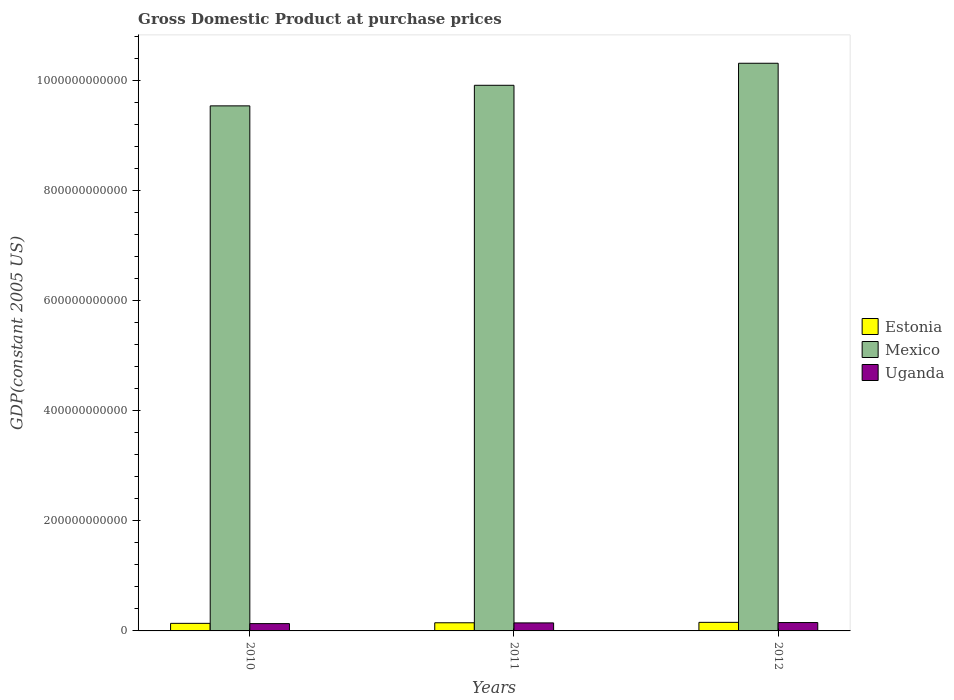How many different coloured bars are there?
Ensure brevity in your answer.  3. How many groups of bars are there?
Offer a terse response. 3. Are the number of bars per tick equal to the number of legend labels?
Offer a terse response. Yes. How many bars are there on the 1st tick from the right?
Ensure brevity in your answer.  3. What is the label of the 1st group of bars from the left?
Your answer should be very brief. 2010. In how many cases, is the number of bars for a given year not equal to the number of legend labels?
Ensure brevity in your answer.  0. What is the GDP at purchase prices in Mexico in 2012?
Your response must be concise. 1.03e+12. Across all years, what is the maximum GDP at purchase prices in Uganda?
Ensure brevity in your answer.  1.52e+1. Across all years, what is the minimum GDP at purchase prices in Estonia?
Give a very brief answer. 1.38e+1. In which year was the GDP at purchase prices in Uganda minimum?
Keep it short and to the point. 2010. What is the total GDP at purchase prices in Estonia in the graph?
Your answer should be compact. 4.41e+1. What is the difference between the GDP at purchase prices in Uganda in 2010 and that in 2012?
Give a very brief answer. -1.93e+09. What is the difference between the GDP at purchase prices in Mexico in 2011 and the GDP at purchase prices in Estonia in 2012?
Provide a short and direct response. 9.75e+11. What is the average GDP at purchase prices in Uganda per year?
Your answer should be very brief. 1.43e+1. In the year 2012, what is the difference between the GDP at purchase prices in Estonia and GDP at purchase prices in Uganda?
Provide a succinct answer. 3.61e+08. What is the ratio of the GDP at purchase prices in Uganda in 2010 to that in 2011?
Offer a terse response. 0.91. Is the GDP at purchase prices in Mexico in 2011 less than that in 2012?
Your answer should be very brief. Yes. Is the difference between the GDP at purchase prices in Estonia in 2010 and 2012 greater than the difference between the GDP at purchase prices in Uganda in 2010 and 2012?
Ensure brevity in your answer.  Yes. What is the difference between the highest and the second highest GDP at purchase prices in Estonia?
Give a very brief answer. 7.67e+08. What is the difference between the highest and the lowest GDP at purchase prices in Uganda?
Offer a terse response. 1.93e+09. In how many years, is the GDP at purchase prices in Estonia greater than the average GDP at purchase prices in Estonia taken over all years?
Offer a very short reply. 2. Is the sum of the GDP at purchase prices in Mexico in 2010 and 2012 greater than the maximum GDP at purchase prices in Uganda across all years?
Offer a very short reply. Yes. What does the 3rd bar from the left in 2011 represents?
Your response must be concise. Uganda. What does the 2nd bar from the right in 2012 represents?
Provide a short and direct response. Mexico. Is it the case that in every year, the sum of the GDP at purchase prices in Uganda and GDP at purchase prices in Mexico is greater than the GDP at purchase prices in Estonia?
Make the answer very short. Yes. What is the difference between two consecutive major ticks on the Y-axis?
Keep it short and to the point. 2.00e+11. Does the graph contain grids?
Ensure brevity in your answer.  No. Where does the legend appear in the graph?
Your answer should be very brief. Center right. What is the title of the graph?
Keep it short and to the point. Gross Domestic Product at purchase prices. Does "Portugal" appear as one of the legend labels in the graph?
Make the answer very short. No. What is the label or title of the Y-axis?
Make the answer very short. GDP(constant 2005 US). What is the GDP(constant 2005 US) in Estonia in 2010?
Ensure brevity in your answer.  1.38e+1. What is the GDP(constant 2005 US) in Mexico in 2010?
Keep it short and to the point. 9.53e+11. What is the GDP(constant 2005 US) in Uganda in 2010?
Your answer should be very brief. 1.33e+1. What is the GDP(constant 2005 US) of Estonia in 2011?
Your answer should be compact. 1.48e+1. What is the GDP(constant 2005 US) of Mexico in 2011?
Keep it short and to the point. 9.91e+11. What is the GDP(constant 2005 US) of Uganda in 2011?
Your answer should be compact. 1.46e+1. What is the GDP(constant 2005 US) in Estonia in 2012?
Keep it short and to the point. 1.56e+1. What is the GDP(constant 2005 US) of Mexico in 2012?
Provide a succinct answer. 1.03e+12. What is the GDP(constant 2005 US) of Uganda in 2012?
Offer a terse response. 1.52e+1. Across all years, what is the maximum GDP(constant 2005 US) of Estonia?
Make the answer very short. 1.56e+1. Across all years, what is the maximum GDP(constant 2005 US) of Mexico?
Ensure brevity in your answer.  1.03e+12. Across all years, what is the maximum GDP(constant 2005 US) of Uganda?
Keep it short and to the point. 1.52e+1. Across all years, what is the minimum GDP(constant 2005 US) of Estonia?
Provide a short and direct response. 1.38e+1. Across all years, what is the minimum GDP(constant 2005 US) of Mexico?
Your response must be concise. 9.53e+11. Across all years, what is the minimum GDP(constant 2005 US) in Uganda?
Ensure brevity in your answer.  1.33e+1. What is the total GDP(constant 2005 US) in Estonia in the graph?
Your answer should be compact. 4.41e+1. What is the total GDP(constant 2005 US) of Mexico in the graph?
Offer a very short reply. 2.98e+12. What is the total GDP(constant 2005 US) in Uganda in the graph?
Provide a succinct answer. 4.30e+1. What is the difference between the GDP(constant 2005 US) in Estonia in 2010 and that in 2011?
Ensure brevity in your answer.  -1.04e+09. What is the difference between the GDP(constant 2005 US) of Mexico in 2010 and that in 2011?
Your answer should be very brief. -3.74e+1. What is the difference between the GDP(constant 2005 US) of Uganda in 2010 and that in 2011?
Offer a terse response. -1.28e+09. What is the difference between the GDP(constant 2005 US) of Estonia in 2010 and that in 2012?
Make the answer very short. -1.81e+09. What is the difference between the GDP(constant 2005 US) in Mexico in 2010 and that in 2012?
Your answer should be very brief. -7.74e+1. What is the difference between the GDP(constant 2005 US) of Uganda in 2010 and that in 2012?
Make the answer very short. -1.93e+09. What is the difference between the GDP(constant 2005 US) in Estonia in 2011 and that in 2012?
Your answer should be compact. -7.67e+08. What is the difference between the GDP(constant 2005 US) of Mexico in 2011 and that in 2012?
Your response must be concise. -4.00e+1. What is the difference between the GDP(constant 2005 US) of Uganda in 2011 and that in 2012?
Your answer should be very brief. -6.42e+08. What is the difference between the GDP(constant 2005 US) of Estonia in 2010 and the GDP(constant 2005 US) of Mexico in 2011?
Provide a succinct answer. -9.77e+11. What is the difference between the GDP(constant 2005 US) of Estonia in 2010 and the GDP(constant 2005 US) of Uganda in 2011?
Provide a short and direct response. -8.06e+08. What is the difference between the GDP(constant 2005 US) in Mexico in 2010 and the GDP(constant 2005 US) in Uganda in 2011?
Your answer should be compact. 9.39e+11. What is the difference between the GDP(constant 2005 US) in Estonia in 2010 and the GDP(constant 2005 US) in Mexico in 2012?
Your response must be concise. -1.02e+12. What is the difference between the GDP(constant 2005 US) of Estonia in 2010 and the GDP(constant 2005 US) of Uganda in 2012?
Ensure brevity in your answer.  -1.45e+09. What is the difference between the GDP(constant 2005 US) of Mexico in 2010 and the GDP(constant 2005 US) of Uganda in 2012?
Offer a terse response. 9.38e+11. What is the difference between the GDP(constant 2005 US) of Estonia in 2011 and the GDP(constant 2005 US) of Mexico in 2012?
Your response must be concise. -1.02e+12. What is the difference between the GDP(constant 2005 US) of Estonia in 2011 and the GDP(constant 2005 US) of Uganda in 2012?
Your response must be concise. -4.06e+08. What is the difference between the GDP(constant 2005 US) in Mexico in 2011 and the GDP(constant 2005 US) in Uganda in 2012?
Your answer should be compact. 9.76e+11. What is the average GDP(constant 2005 US) of Estonia per year?
Offer a very short reply. 1.47e+1. What is the average GDP(constant 2005 US) of Mexico per year?
Offer a very short reply. 9.92e+11. What is the average GDP(constant 2005 US) of Uganda per year?
Your answer should be very brief. 1.43e+1. In the year 2010, what is the difference between the GDP(constant 2005 US) in Estonia and GDP(constant 2005 US) in Mexico?
Provide a succinct answer. -9.40e+11. In the year 2010, what is the difference between the GDP(constant 2005 US) of Estonia and GDP(constant 2005 US) of Uganda?
Make the answer very short. 4.78e+08. In the year 2010, what is the difference between the GDP(constant 2005 US) of Mexico and GDP(constant 2005 US) of Uganda?
Your response must be concise. 9.40e+11. In the year 2011, what is the difference between the GDP(constant 2005 US) of Estonia and GDP(constant 2005 US) of Mexico?
Provide a short and direct response. -9.76e+11. In the year 2011, what is the difference between the GDP(constant 2005 US) of Estonia and GDP(constant 2005 US) of Uganda?
Ensure brevity in your answer.  2.37e+08. In the year 2011, what is the difference between the GDP(constant 2005 US) of Mexico and GDP(constant 2005 US) of Uganda?
Offer a very short reply. 9.76e+11. In the year 2012, what is the difference between the GDP(constant 2005 US) of Estonia and GDP(constant 2005 US) of Mexico?
Offer a very short reply. -1.02e+12. In the year 2012, what is the difference between the GDP(constant 2005 US) in Estonia and GDP(constant 2005 US) in Uganda?
Provide a short and direct response. 3.61e+08. In the year 2012, what is the difference between the GDP(constant 2005 US) of Mexico and GDP(constant 2005 US) of Uganda?
Ensure brevity in your answer.  1.02e+12. What is the ratio of the GDP(constant 2005 US) of Estonia in 2010 to that in 2011?
Give a very brief answer. 0.93. What is the ratio of the GDP(constant 2005 US) of Mexico in 2010 to that in 2011?
Keep it short and to the point. 0.96. What is the ratio of the GDP(constant 2005 US) in Uganda in 2010 to that in 2011?
Keep it short and to the point. 0.91. What is the ratio of the GDP(constant 2005 US) in Estonia in 2010 to that in 2012?
Your response must be concise. 0.88. What is the ratio of the GDP(constant 2005 US) in Mexico in 2010 to that in 2012?
Keep it short and to the point. 0.92. What is the ratio of the GDP(constant 2005 US) of Uganda in 2010 to that in 2012?
Offer a terse response. 0.87. What is the ratio of the GDP(constant 2005 US) in Estonia in 2011 to that in 2012?
Your answer should be compact. 0.95. What is the ratio of the GDP(constant 2005 US) of Mexico in 2011 to that in 2012?
Your response must be concise. 0.96. What is the ratio of the GDP(constant 2005 US) in Uganda in 2011 to that in 2012?
Offer a terse response. 0.96. What is the difference between the highest and the second highest GDP(constant 2005 US) of Estonia?
Give a very brief answer. 7.67e+08. What is the difference between the highest and the second highest GDP(constant 2005 US) in Mexico?
Your answer should be compact. 4.00e+1. What is the difference between the highest and the second highest GDP(constant 2005 US) in Uganda?
Keep it short and to the point. 6.42e+08. What is the difference between the highest and the lowest GDP(constant 2005 US) in Estonia?
Provide a short and direct response. 1.81e+09. What is the difference between the highest and the lowest GDP(constant 2005 US) of Mexico?
Give a very brief answer. 7.74e+1. What is the difference between the highest and the lowest GDP(constant 2005 US) in Uganda?
Provide a succinct answer. 1.93e+09. 